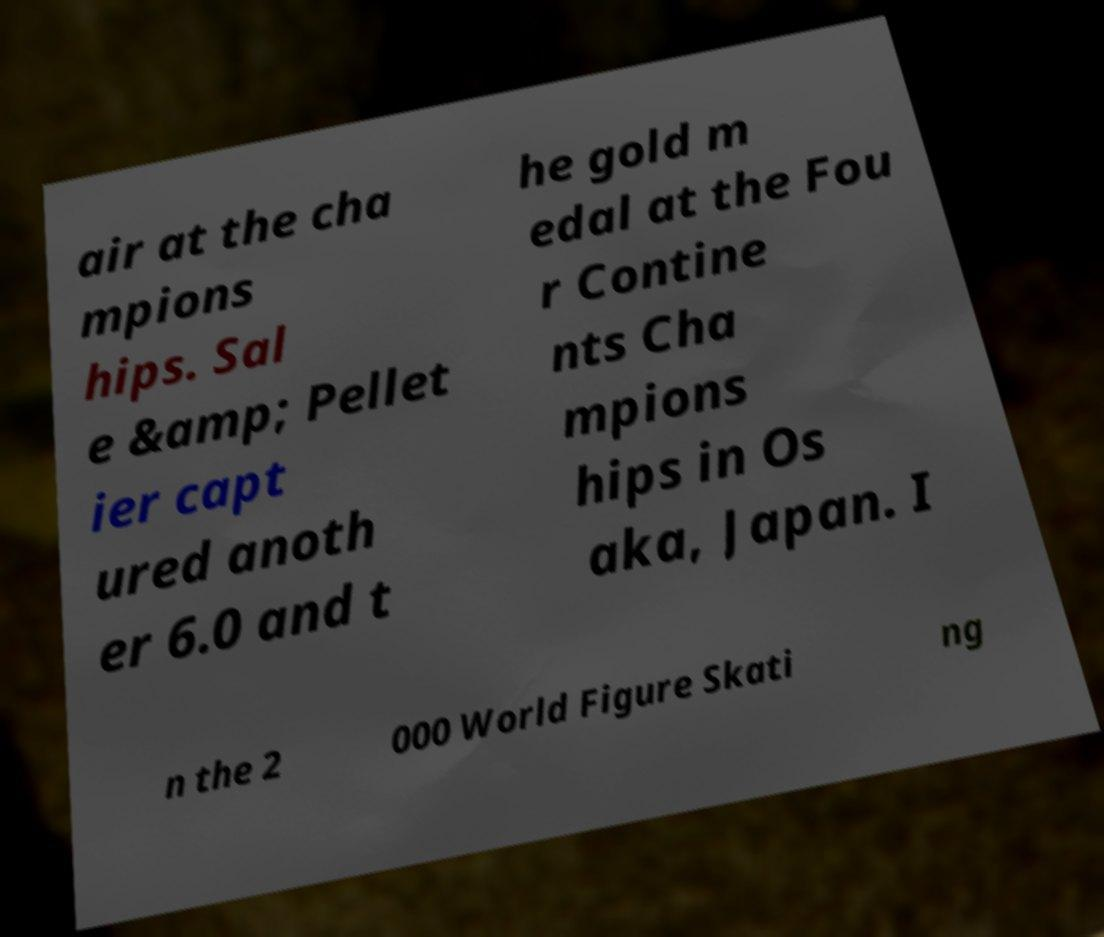Could you assist in decoding the text presented in this image and type it out clearly? air at the cha mpions hips. Sal e &amp; Pellet ier capt ured anoth er 6.0 and t he gold m edal at the Fou r Contine nts Cha mpions hips in Os aka, Japan. I n the 2 000 World Figure Skati ng 